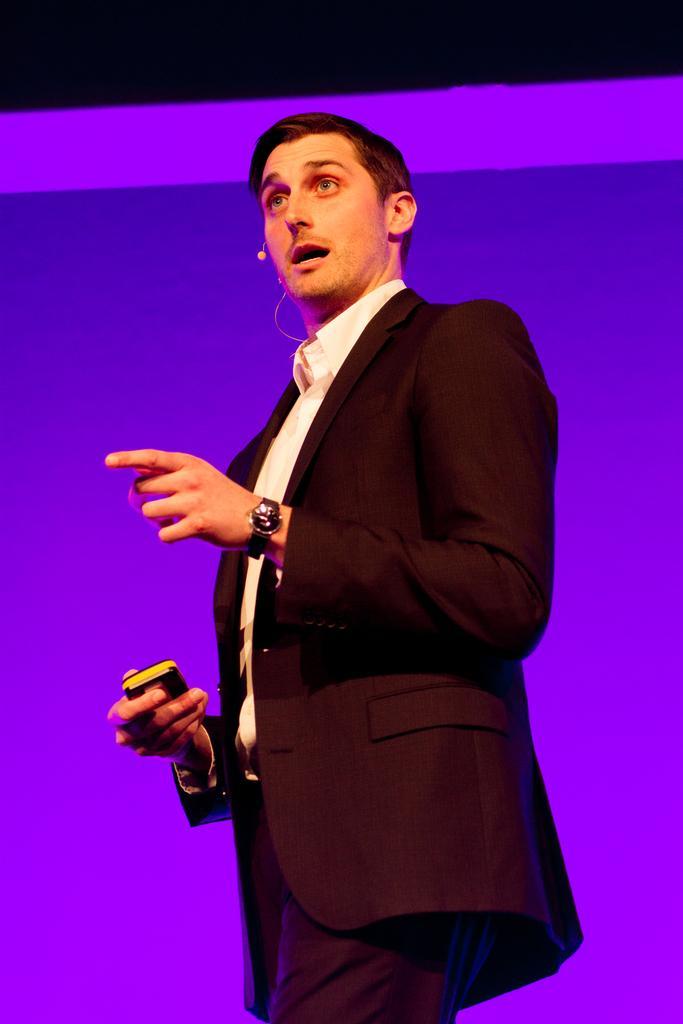Could you give a brief overview of what you see in this image? In this image I see a man who is wearing a suit which is of black in color and I can also see that he is wearing white shirt and I see he is holding a thing in his hand and I see the wire and a thing over here and it is purple and blue color in the background and it is dark over here. 